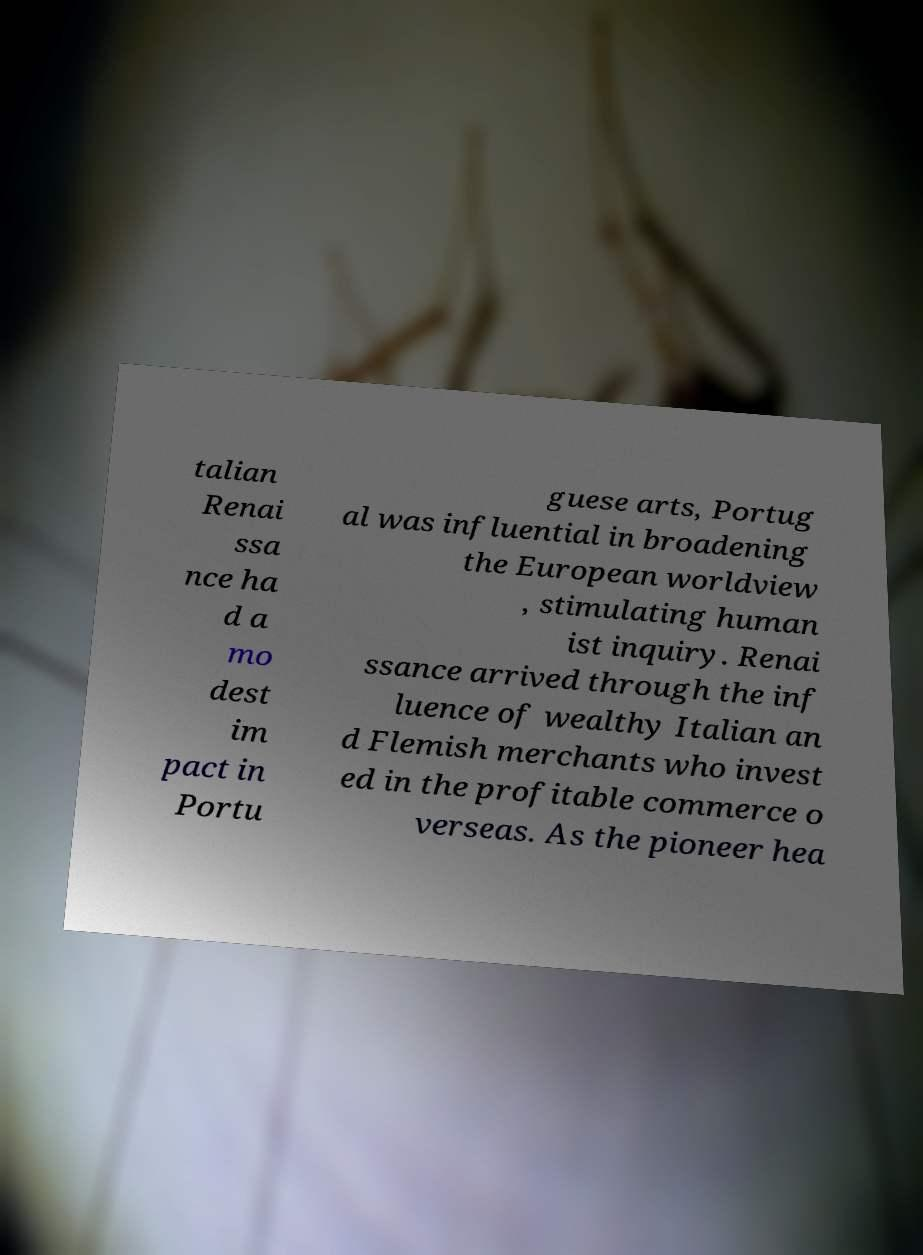There's text embedded in this image that I need extracted. Can you transcribe it verbatim? talian Renai ssa nce ha d a mo dest im pact in Portu guese arts, Portug al was influential in broadening the European worldview , stimulating human ist inquiry. Renai ssance arrived through the inf luence of wealthy Italian an d Flemish merchants who invest ed in the profitable commerce o verseas. As the pioneer hea 